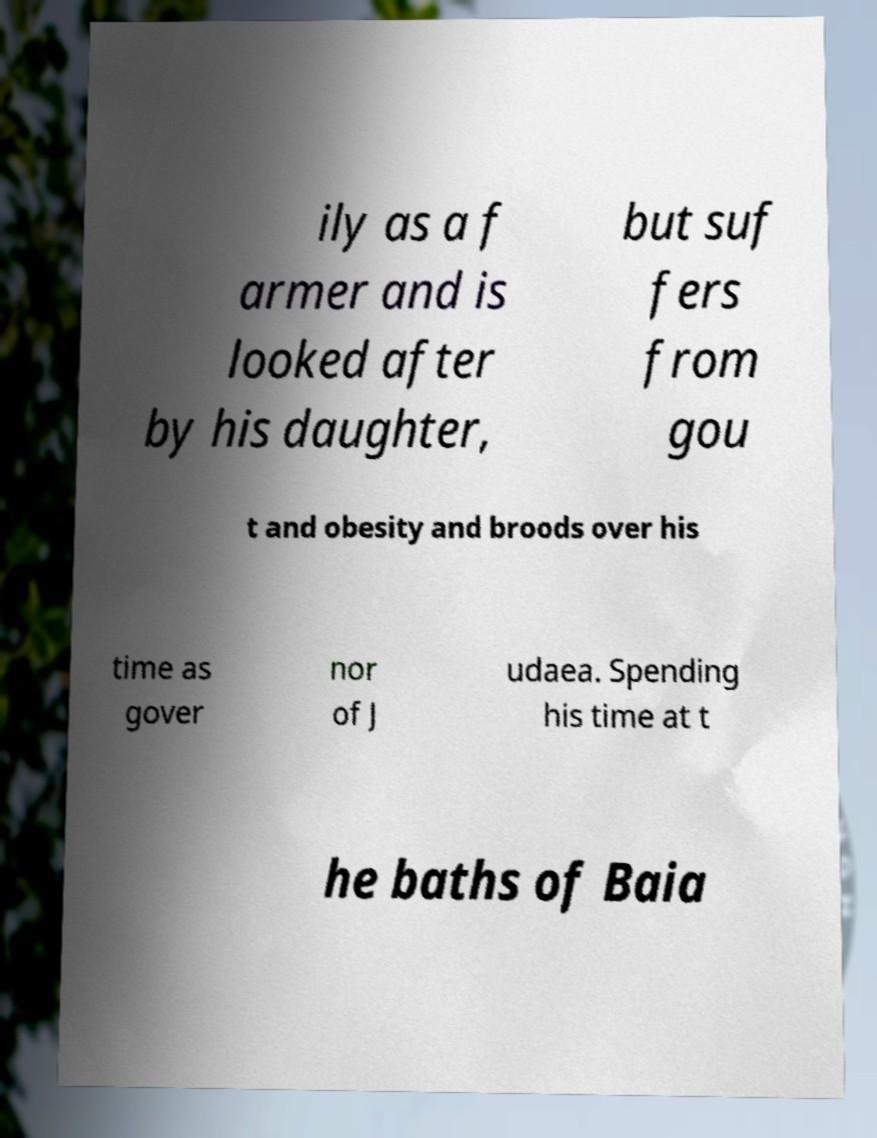What messages or text are displayed in this image? I need them in a readable, typed format. ily as a f armer and is looked after by his daughter, but suf fers from gou t and obesity and broods over his time as gover nor of J udaea. Spending his time at t he baths of Baia 